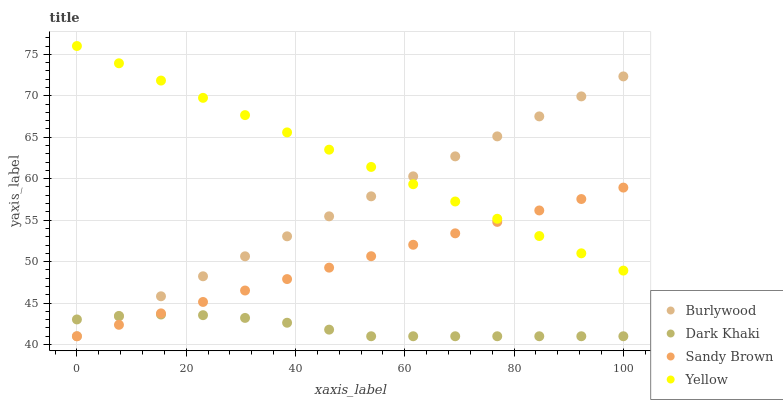Does Dark Khaki have the minimum area under the curve?
Answer yes or no. Yes. Does Yellow have the maximum area under the curve?
Answer yes or no. Yes. Does Sandy Brown have the minimum area under the curve?
Answer yes or no. No. Does Sandy Brown have the maximum area under the curve?
Answer yes or no. No. Is Yellow the smoothest?
Answer yes or no. Yes. Is Dark Khaki the roughest?
Answer yes or no. Yes. Is Sandy Brown the smoothest?
Answer yes or no. No. Is Sandy Brown the roughest?
Answer yes or no. No. Does Burlywood have the lowest value?
Answer yes or no. Yes. Does Yellow have the lowest value?
Answer yes or no. No. Does Yellow have the highest value?
Answer yes or no. Yes. Does Sandy Brown have the highest value?
Answer yes or no. No. Is Dark Khaki less than Yellow?
Answer yes or no. Yes. Is Yellow greater than Dark Khaki?
Answer yes or no. Yes. Does Dark Khaki intersect Burlywood?
Answer yes or no. Yes. Is Dark Khaki less than Burlywood?
Answer yes or no. No. Is Dark Khaki greater than Burlywood?
Answer yes or no. No. Does Dark Khaki intersect Yellow?
Answer yes or no. No. 